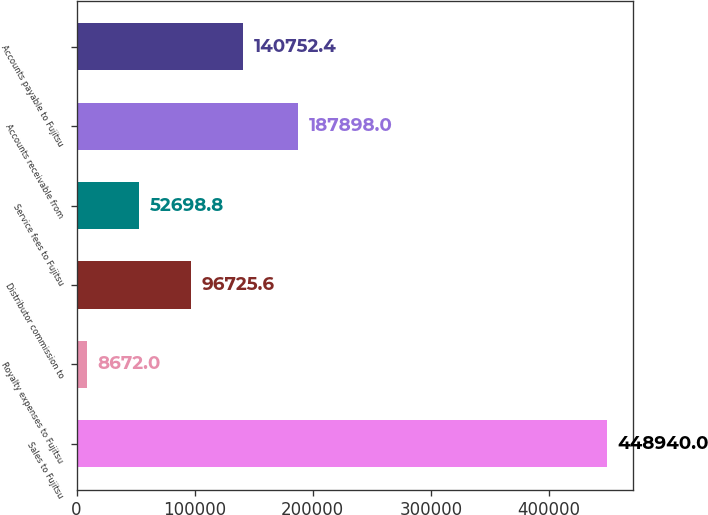Convert chart to OTSL. <chart><loc_0><loc_0><loc_500><loc_500><bar_chart><fcel>Sales to Fujitsu<fcel>Royalty expenses to Fujitsu<fcel>Distributor commission to<fcel>Service fees to Fujitsu<fcel>Accounts receivable from<fcel>Accounts payable to Fujitsu<nl><fcel>448940<fcel>8672<fcel>96725.6<fcel>52698.8<fcel>187898<fcel>140752<nl></chart> 